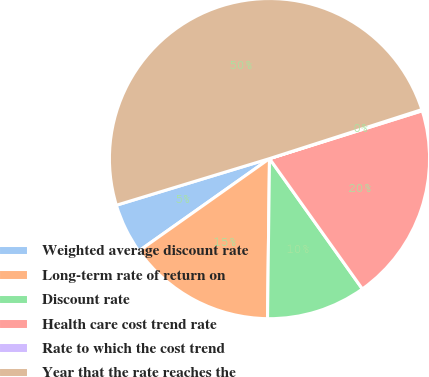Convert chart. <chart><loc_0><loc_0><loc_500><loc_500><pie_chart><fcel>Weighted average discount rate<fcel>Long-term rate of return on<fcel>Discount rate<fcel>Health care cost trend rate<fcel>Rate to which the cost trend<fcel>Year that the rate reaches the<nl><fcel>5.09%<fcel>15.01%<fcel>10.05%<fcel>19.98%<fcel>0.12%<fcel>49.75%<nl></chart> 